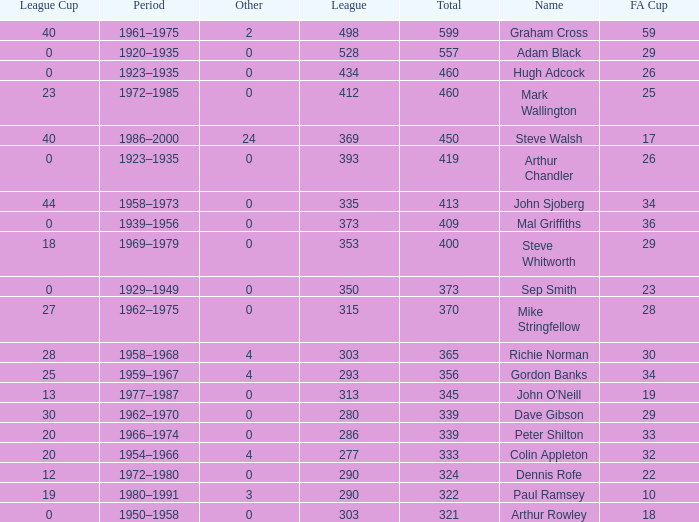What is the average number of FA cups Steve Whitworth, who has less than 400 total, has? None. 